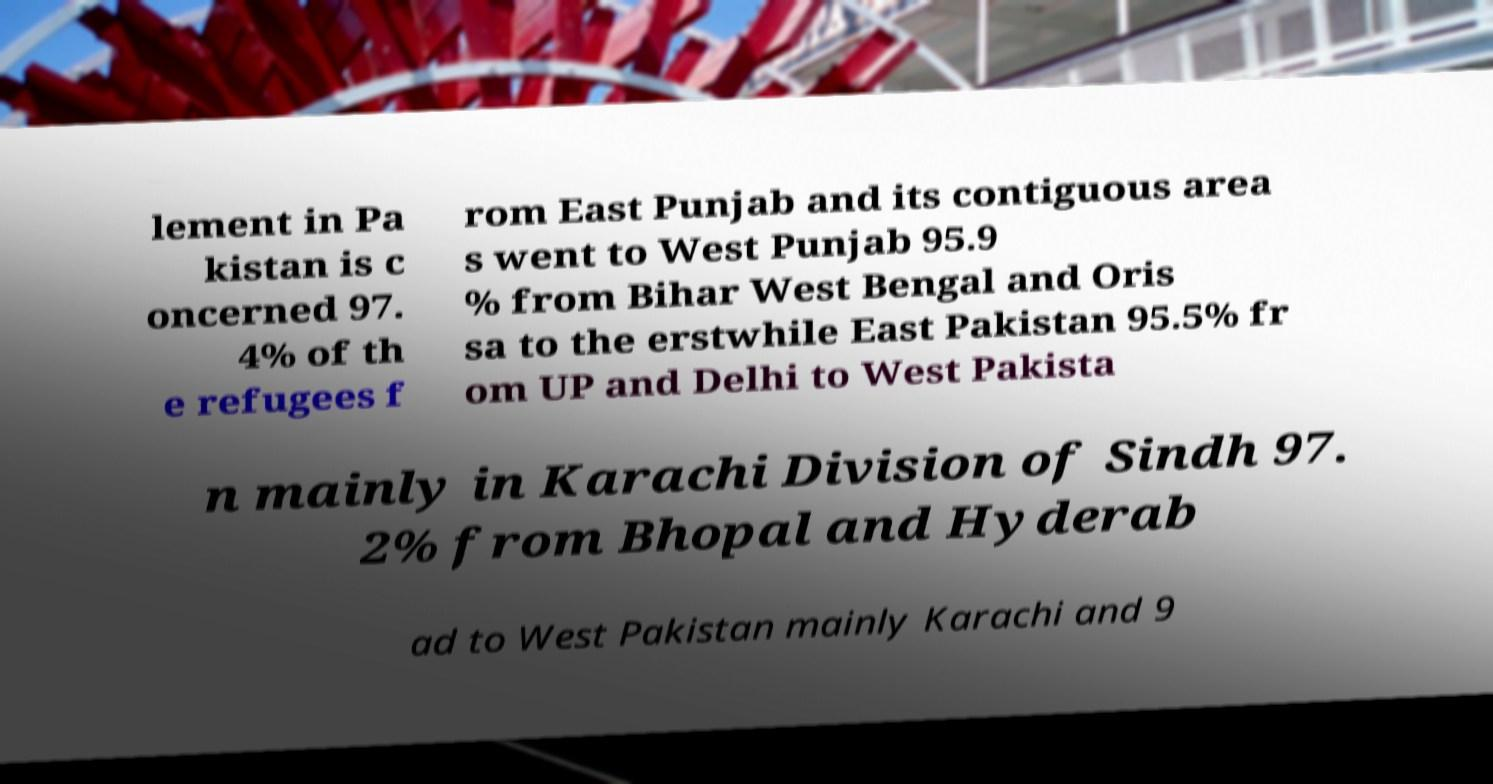Could you extract and type out the text from this image? lement in Pa kistan is c oncerned 97. 4% of th e refugees f rom East Punjab and its contiguous area s went to West Punjab 95.9 % from Bihar West Bengal and Oris sa to the erstwhile East Pakistan 95.5% fr om UP and Delhi to West Pakista n mainly in Karachi Division of Sindh 97. 2% from Bhopal and Hyderab ad to West Pakistan mainly Karachi and 9 